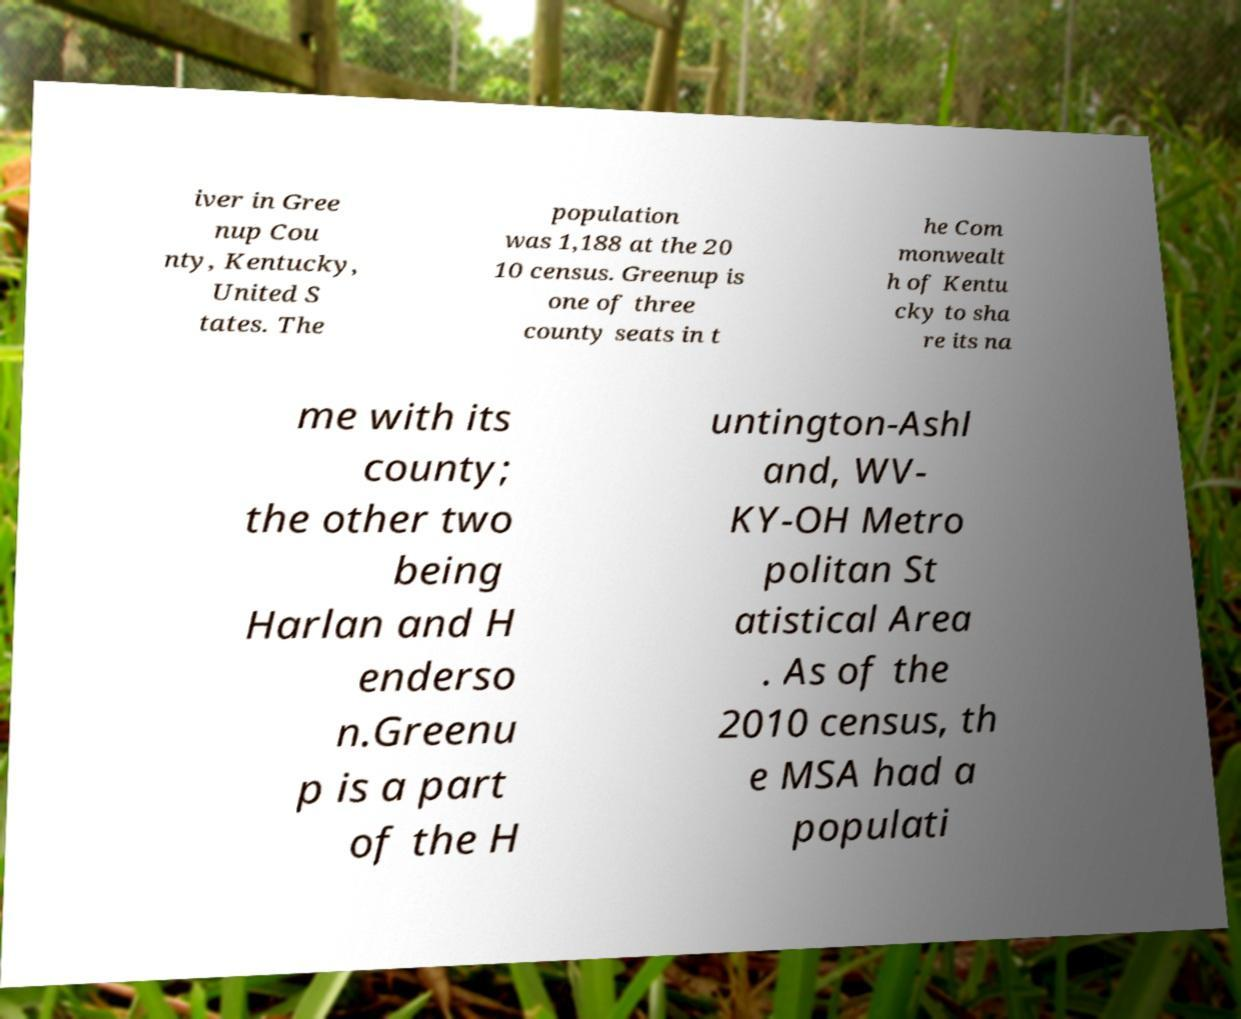Could you assist in decoding the text presented in this image and type it out clearly? iver in Gree nup Cou nty, Kentucky, United S tates. The population was 1,188 at the 20 10 census. Greenup is one of three county seats in t he Com monwealt h of Kentu cky to sha re its na me with its county; the other two being Harlan and H enderso n.Greenu p is a part of the H untington-Ashl and, WV- KY-OH Metro politan St atistical Area . As of the 2010 census, th e MSA had a populati 